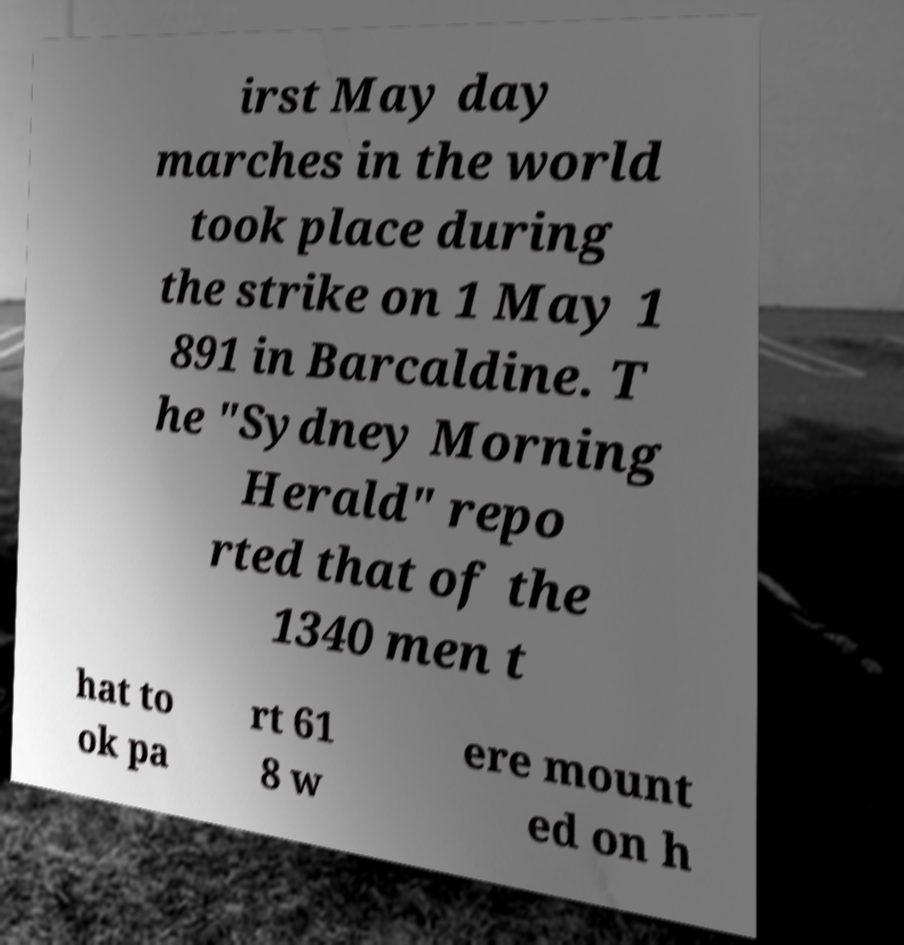There's text embedded in this image that I need extracted. Can you transcribe it verbatim? irst May day marches in the world took place during the strike on 1 May 1 891 in Barcaldine. T he "Sydney Morning Herald" repo rted that of the 1340 men t hat to ok pa rt 61 8 w ere mount ed on h 